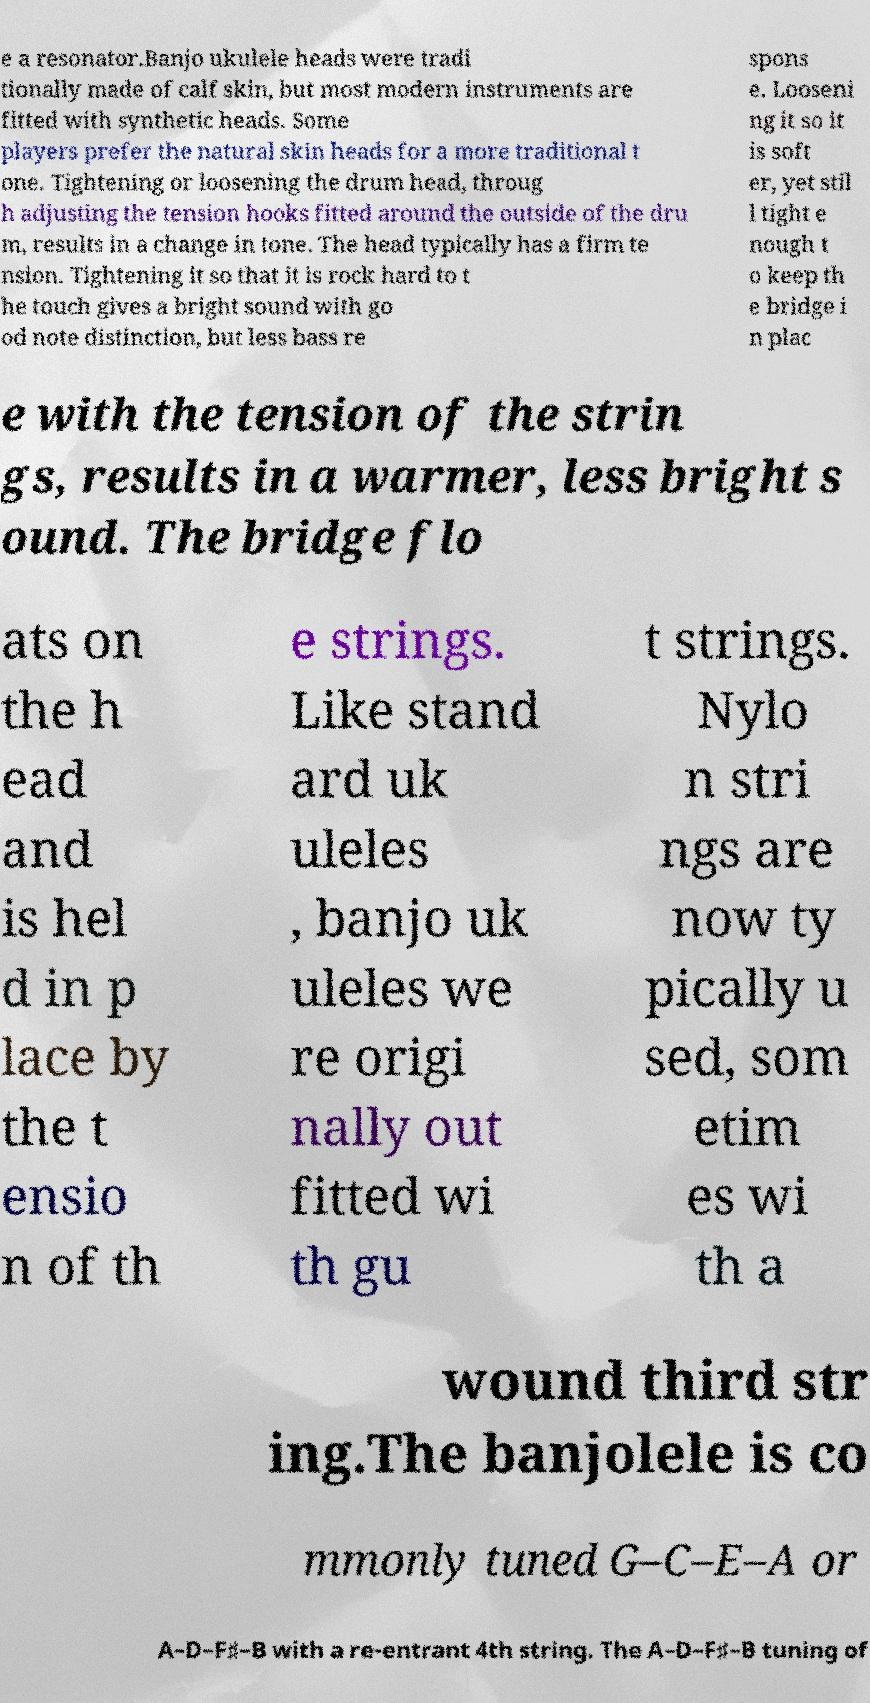What messages or text are displayed in this image? I need them in a readable, typed format. e a resonator.Banjo ukulele heads were tradi tionally made of calf skin, but most modern instruments are fitted with synthetic heads. Some players prefer the natural skin heads for a more traditional t one. Tightening or loosening the drum head, throug h adjusting the tension hooks fitted around the outside of the dru m, results in a change in tone. The head typically has a firm te nsion. Tightening it so that it is rock hard to t he touch gives a bright sound with go od note distinction, but less bass re spons e. Looseni ng it so it is soft er, yet stil l tight e nough t o keep th e bridge i n plac e with the tension of the strin gs, results in a warmer, less bright s ound. The bridge flo ats on the h ead and is hel d in p lace by the t ensio n of th e strings. Like stand ard uk uleles , banjo uk uleles we re origi nally out fitted wi th gu t strings. Nylo n stri ngs are now ty pically u sed, som etim es wi th a wound third str ing.The banjolele is co mmonly tuned G–C–E–A or A–D–F♯–B with a re-entrant 4th string. The A–D–F♯–B tuning of 